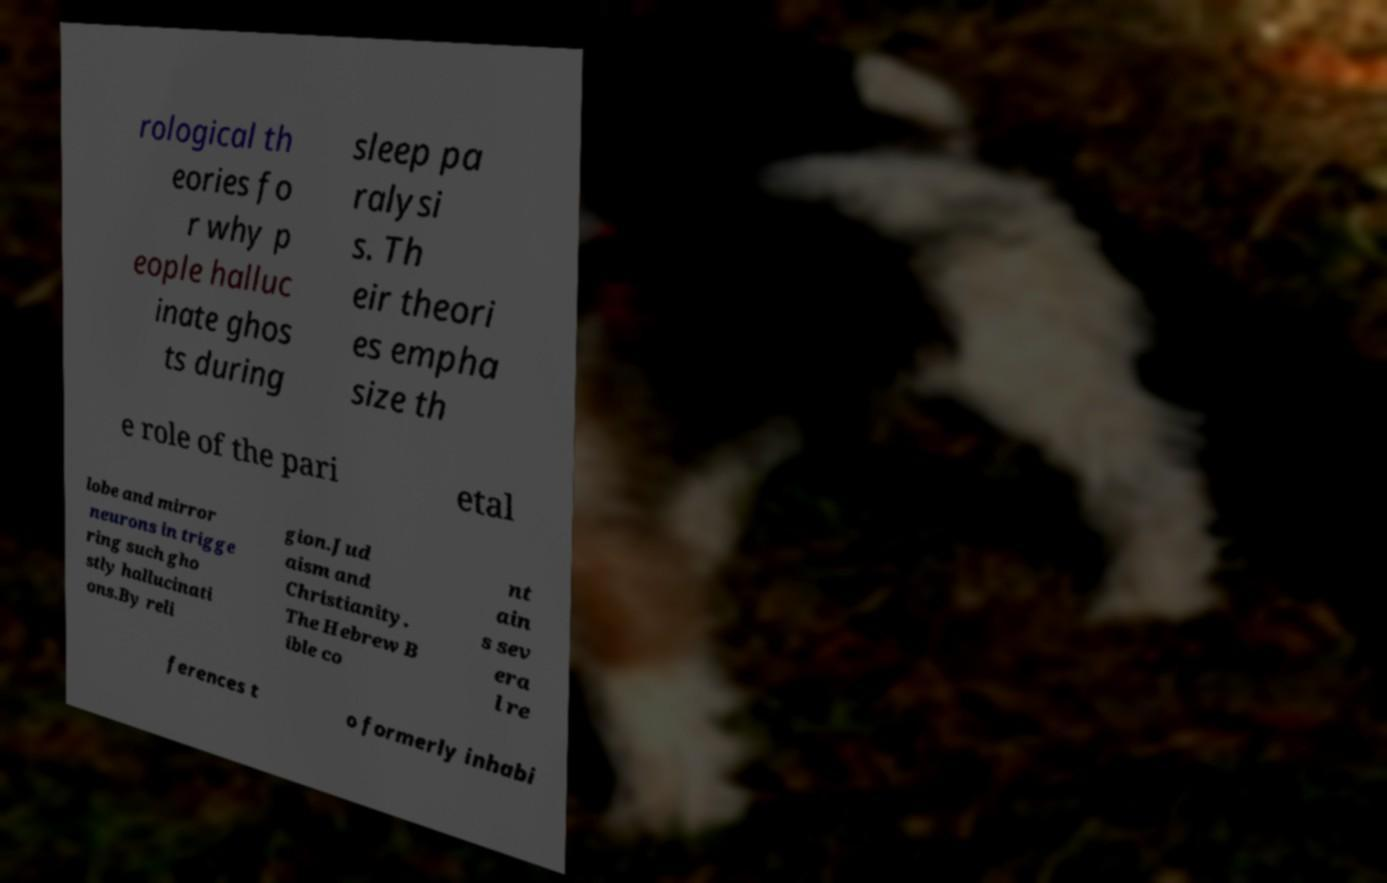What messages or text are displayed in this image? I need them in a readable, typed format. rological th eories fo r why p eople halluc inate ghos ts during sleep pa ralysi s. Th eir theori es empha size th e role of the pari etal lobe and mirror neurons in trigge ring such gho stly hallucinati ons.By reli gion.Jud aism and Christianity. The Hebrew B ible co nt ain s sev era l re ferences t o formerly inhabi 